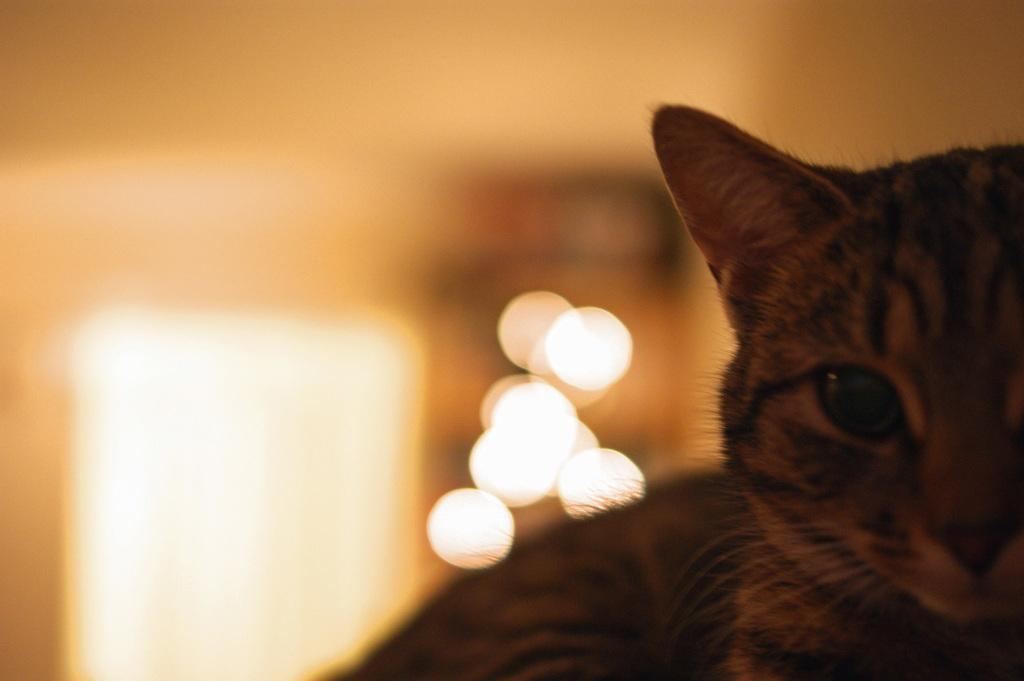What type of animal is in the image? There is a cat in the image. Can you describe the background of the image? The background of the image is blurred. What does the caption say about the cat's ability to jump in the image? There is no caption present in the image, and therefore no information about the cat's ability to jump can be determined. 